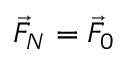<formula> <loc_0><loc_0><loc_500><loc_500>\vec { F } _ { N } = \vec { F } _ { 0 }</formula> 